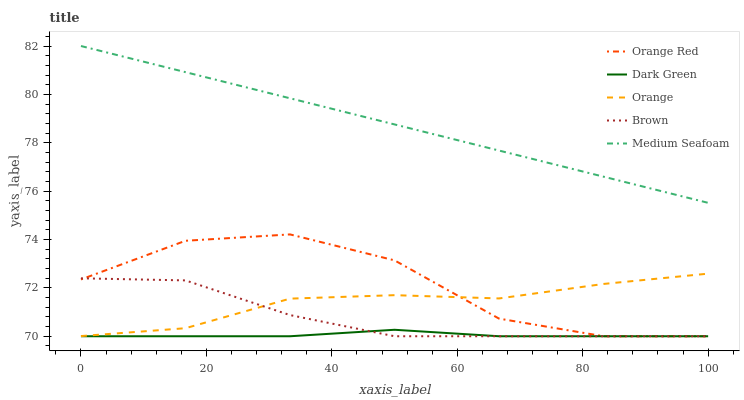Does Dark Green have the minimum area under the curve?
Answer yes or no. Yes. Does Medium Seafoam have the maximum area under the curve?
Answer yes or no. Yes. Does Brown have the minimum area under the curve?
Answer yes or no. No. Does Brown have the maximum area under the curve?
Answer yes or no. No. Is Medium Seafoam the smoothest?
Answer yes or no. Yes. Is Orange Red the roughest?
Answer yes or no. Yes. Is Brown the smoothest?
Answer yes or no. No. Is Brown the roughest?
Answer yes or no. No. Does Brown have the lowest value?
Answer yes or no. Yes. Does Medium Seafoam have the lowest value?
Answer yes or no. No. Does Medium Seafoam have the highest value?
Answer yes or no. Yes. Does Brown have the highest value?
Answer yes or no. No. Is Brown less than Medium Seafoam?
Answer yes or no. Yes. Is Medium Seafoam greater than Brown?
Answer yes or no. Yes. Does Orange Red intersect Brown?
Answer yes or no. Yes. Is Orange Red less than Brown?
Answer yes or no. No. Is Orange Red greater than Brown?
Answer yes or no. No. Does Brown intersect Medium Seafoam?
Answer yes or no. No. 